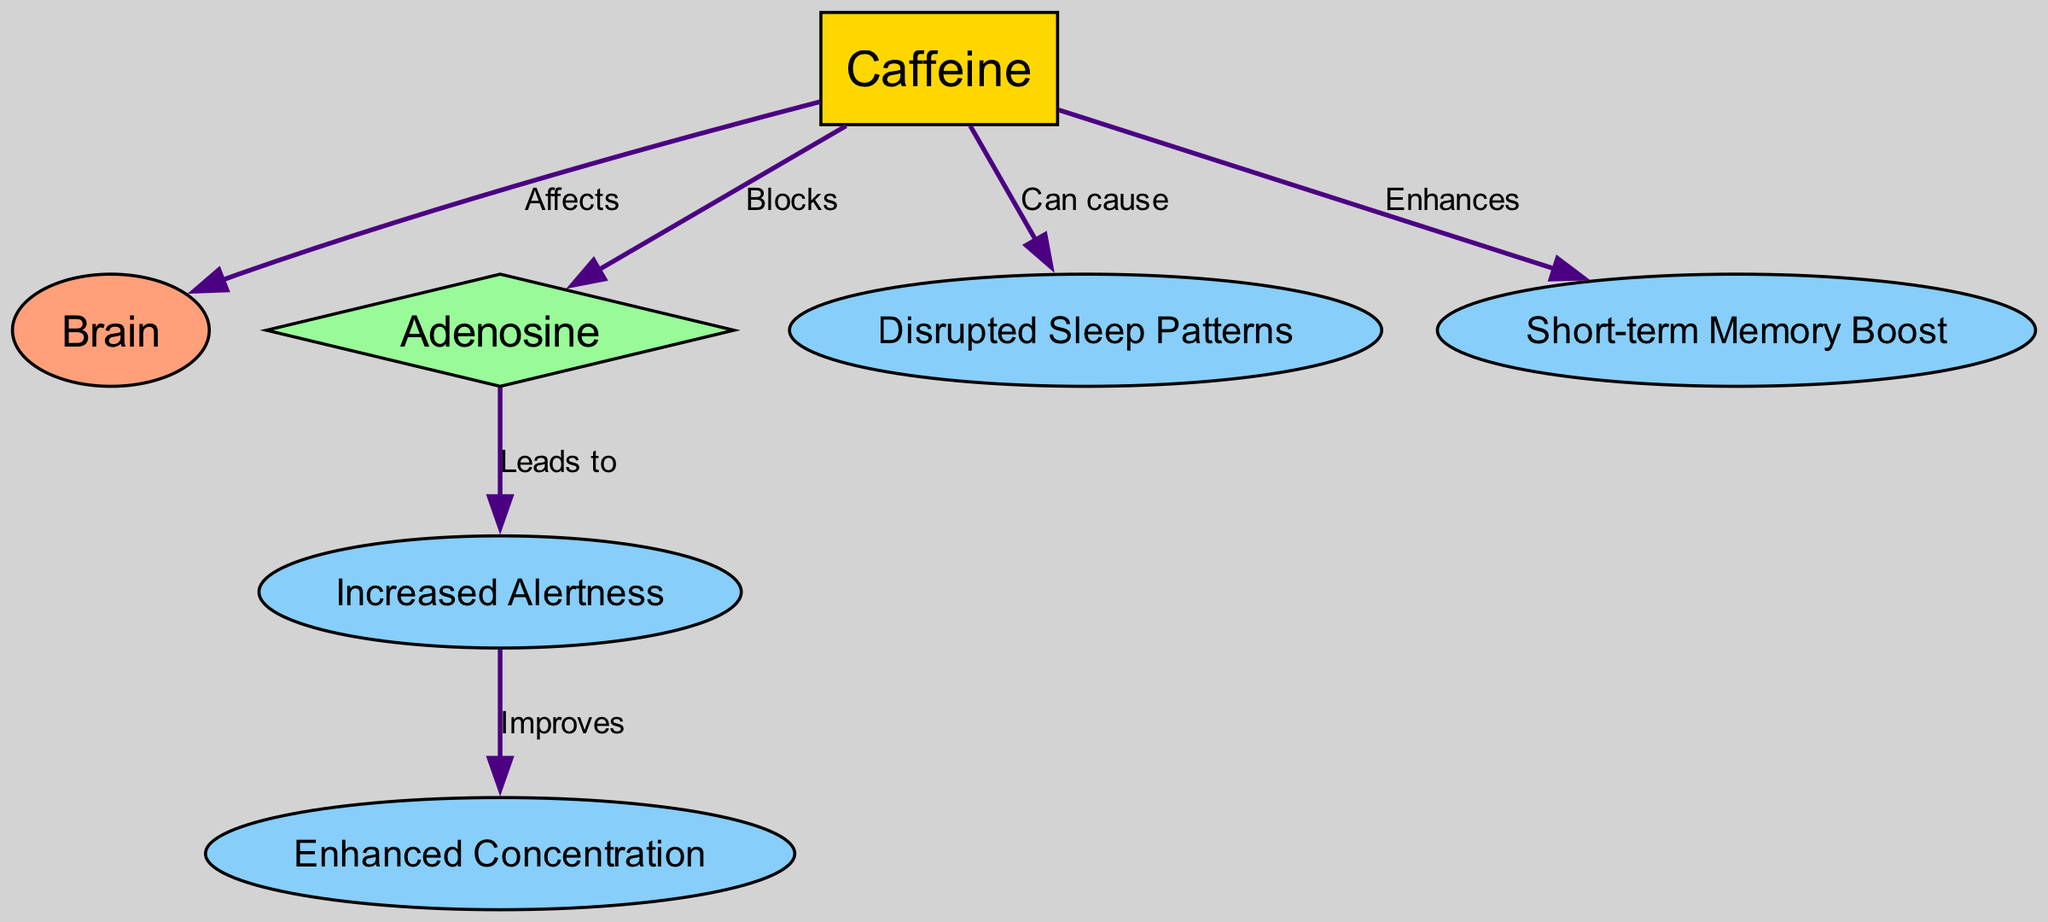What is the primary substance influencing the central nervous system in this diagram? The diagram indicates that the primary substance is "Caffeine," as it is the central node affecting multiple aspects of the central nervous system.
Answer: Caffeine How many total nodes are represented in the diagram? The diagram lists seven different nodes: caffeine, brain, adenosine, increased alertness, enhanced concentration, disrupted sleep patterns, and short-term memory boost, making the total count seven.
Answer: 7 What effect does caffeine have on adenosine? The relationship shows that caffeine "Blocks" adenosine, indicating a direct interaction where caffeine inhibits the action of adenosine.
Answer: Blocks Which node results from the interaction of increased alertness? The interaction leads to "Enhanced Concentration." The edge labeled "Improves" connects these two concepts in the diagram.
Answer: Enhanced Concentration What is one potential negative effect of caffeine mentioned in the diagram? The diagram specifies "Disrupted Sleep Patterns" as a potential negative effect of caffeine consumption, indicating possible consequences of its use.
Answer: Disrupted Sleep Patterns How does caffeine enhance short-term memory? Caffeine "Enhances" short-term memory, as shown by the direct edge connecting caffeine to the memory node, indicating a positive impact on memory performance.
Answer: Enhances What does adenosine lead to in the context of the diagram? According to the diagram, adenosine "Leads to Increased Alertness," showing a causal relationship between these two elements.
Answer: Increased Alertness What effect does caffeine exert on the brain? The diagram states that caffeine "Affects" the brain, indicating its influential role on brain function during late-night study sessions.
Answer: Affects How many edges are there in the diagram? The diagram contains six edges connecting the various nodes, which illustrate the relationships and flows of influence among them.
Answer: 6 